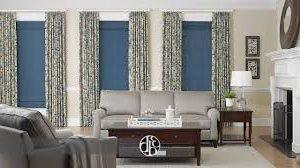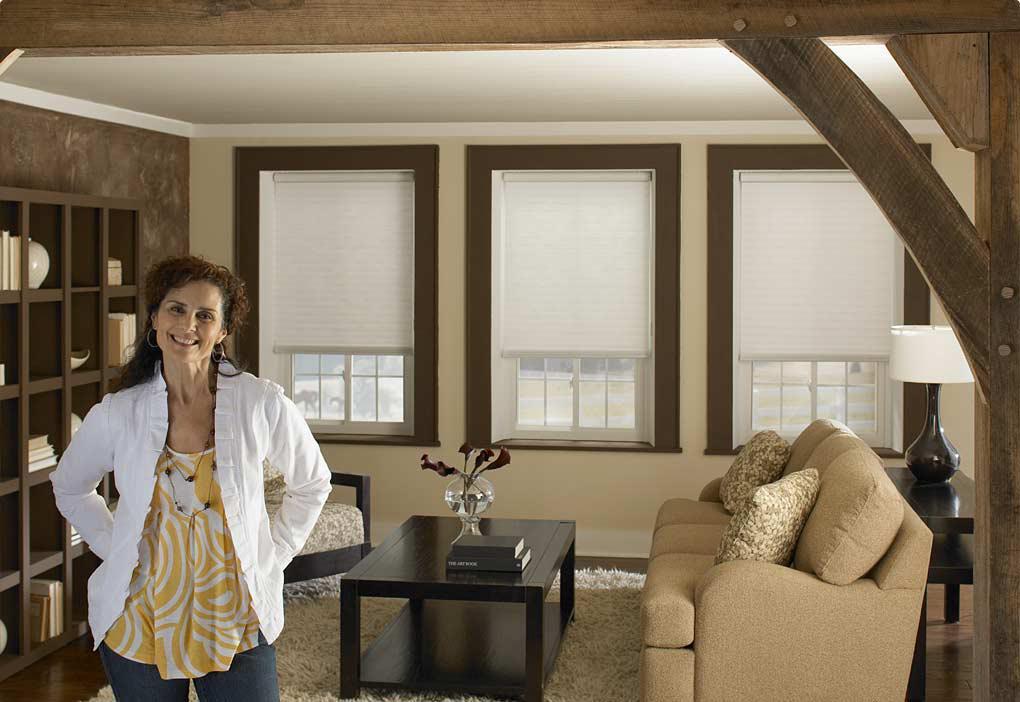The first image is the image on the left, the second image is the image on the right. Given the left and right images, does the statement "There are five blinds." hold true? Answer yes or no. No. 